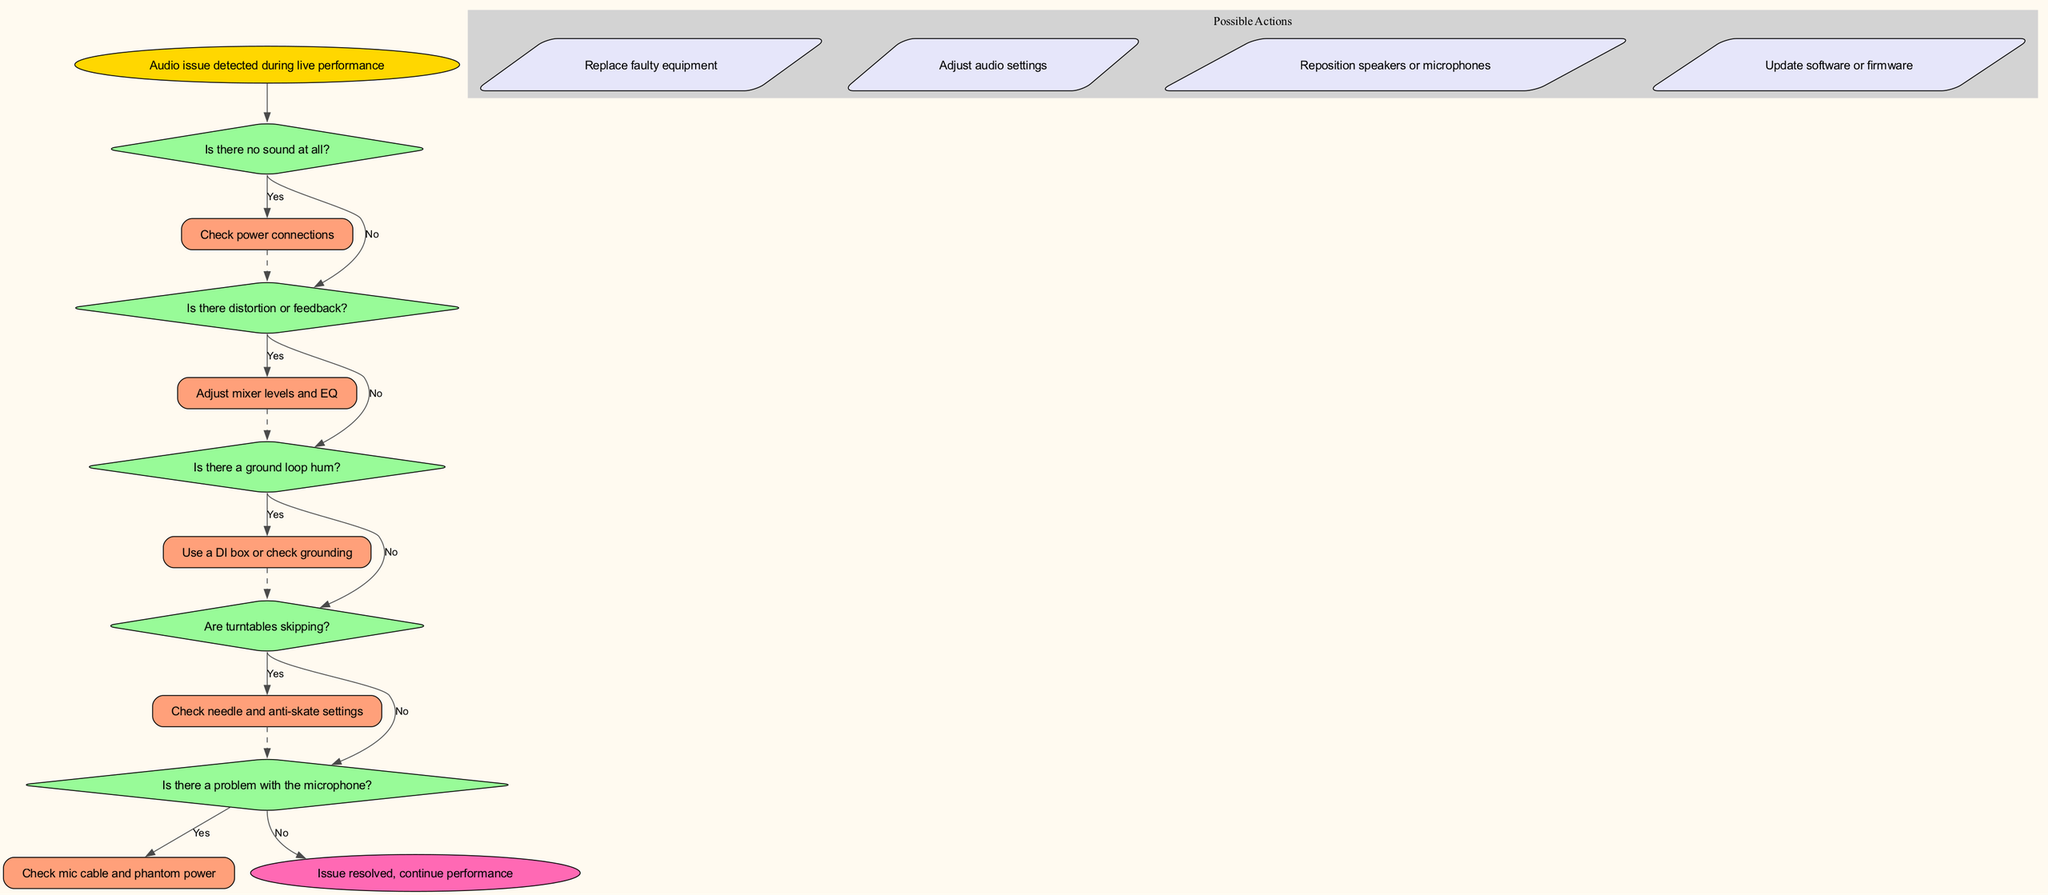What is the first step in the troubleshooting process? The first step in the diagram is to detect an audio issue during the live performance, which sets the process in motion.
Answer: Audio issue detected during live performance How many decision points are present in the diagram? There are five decision points in the diagram, each addressing different audio issues that may arise.
Answer: 5 What should be checked if there is no sound at all? If there is no sound at all, the next step according to the diagram is to check the power connections.
Answer: Check power connections If distortion or feedback is experienced, what action should be taken? In the case of distortion or feedback, the diagram suggests adjusting the mixer levels and EQ to resolve the issue.
Answer: Adjust mixer levels and EQ What is the action recommended if turntables are skipping? When turntables are skipping, the recommended action is to check the needle and anti-skate settings for proper functioning.
Answer: Check needle and anti-skate settings What happens if there is a problem detected with the microphone? If a problem is detected with the microphone, the diagram instructs to check the mic cable and phantom power to identify the issue.
Answer: Check mic cable and phantom power What type of nodes represent possible actions in the flowchart? The possible actions are represented by parallelogram-shaped nodes within a cluster, indicating distinct actions that could resolve issues.
Answer: Parallelogram What is the outcome if all checks do not reveal an issue? If all previous checks do not reveal an issue, the diagram indicates to consult a sound engineer for further assistance.
Answer: Consult sound engineer What kind of connections are used between decision nodes? The connections between decision nodes are primarily directed edges indicating yes or no answers that guide the troubleshooting process.
Answer: Directed edges 